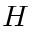<formula> <loc_0><loc_0><loc_500><loc_500>H</formula> 